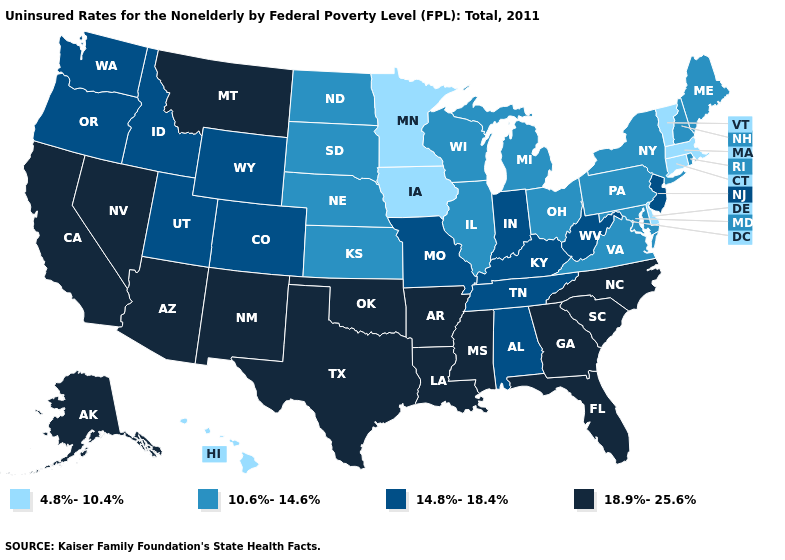Does New Hampshire have a lower value than Kansas?
Answer briefly. No. Does New Hampshire have a higher value than West Virginia?
Write a very short answer. No. Name the states that have a value in the range 4.8%-10.4%?
Write a very short answer. Connecticut, Delaware, Hawaii, Iowa, Massachusetts, Minnesota, Vermont. Name the states that have a value in the range 10.6%-14.6%?
Be succinct. Illinois, Kansas, Maine, Maryland, Michigan, Nebraska, New Hampshire, New York, North Dakota, Ohio, Pennsylvania, Rhode Island, South Dakota, Virginia, Wisconsin. How many symbols are there in the legend?
Short answer required. 4. What is the value of Texas?
Short answer required. 18.9%-25.6%. Name the states that have a value in the range 4.8%-10.4%?
Be succinct. Connecticut, Delaware, Hawaii, Iowa, Massachusetts, Minnesota, Vermont. What is the highest value in the USA?
Short answer required. 18.9%-25.6%. Does the first symbol in the legend represent the smallest category?
Quick response, please. Yes. What is the value of Florida?
Answer briefly. 18.9%-25.6%. Name the states that have a value in the range 18.9%-25.6%?
Keep it brief. Alaska, Arizona, Arkansas, California, Florida, Georgia, Louisiana, Mississippi, Montana, Nevada, New Mexico, North Carolina, Oklahoma, South Carolina, Texas. Among the states that border Delaware , which have the lowest value?
Be succinct. Maryland, Pennsylvania. What is the value of Virginia?
Short answer required. 10.6%-14.6%. Does the first symbol in the legend represent the smallest category?
Answer briefly. Yes. Does the first symbol in the legend represent the smallest category?
Short answer required. Yes. 